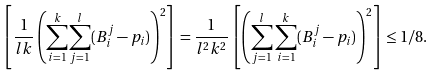<formula> <loc_0><loc_0><loc_500><loc_500>\left [ \frac { 1 } { l k } \left ( \underset { i = 1 } { \overset { k } { \sum } } \underset { j = 1 } { \overset { l } { \sum } } ( B ^ { j } _ { i } - p _ { i } ) \right ) ^ { 2 } \right ] & = \frac { 1 } { l ^ { 2 } k ^ { 2 } } \left [ \left ( \sum _ { j = 1 } ^ { l } \sum _ { i = 1 } ^ { k } ( B _ { i } ^ { j } - p _ { i } ) \right ) ^ { 2 } \right ] \leq 1 / 8 .</formula> 